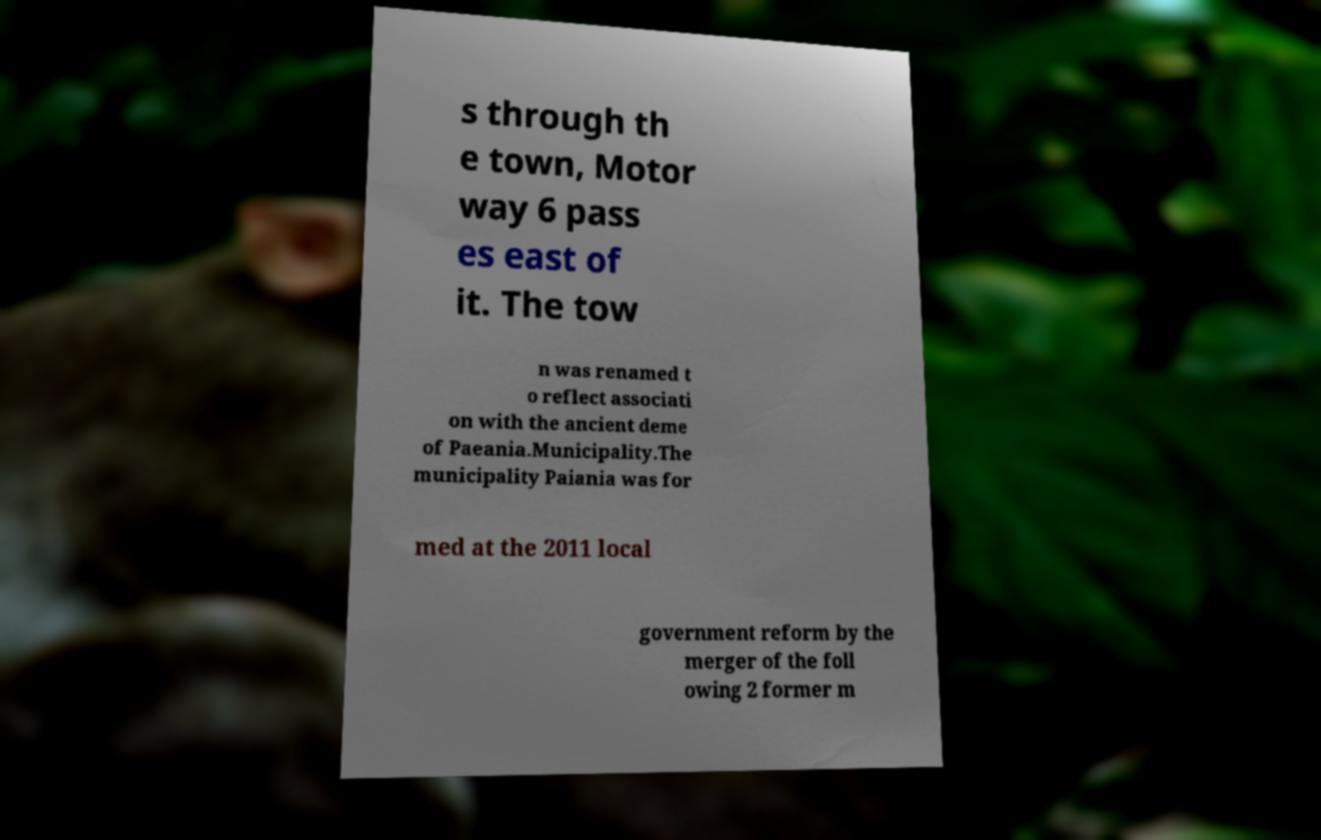Can you read and provide the text displayed in the image?This photo seems to have some interesting text. Can you extract and type it out for me? s through th e town, Motor way 6 pass es east of it. The tow n was renamed t o reflect associati on with the ancient deme of Paeania.Municipality.The municipality Paiania was for med at the 2011 local government reform by the merger of the foll owing 2 former m 